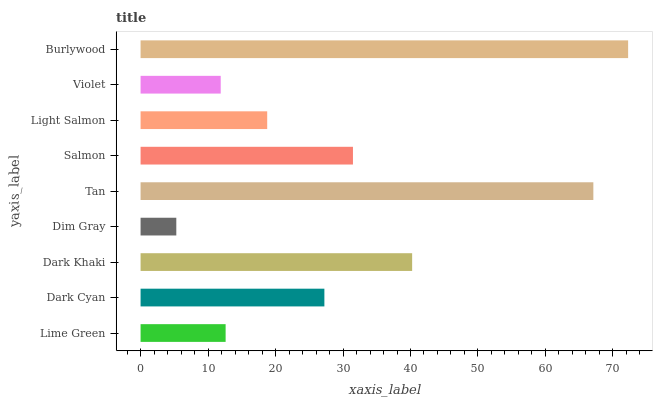Is Dim Gray the minimum?
Answer yes or no. Yes. Is Burlywood the maximum?
Answer yes or no. Yes. Is Dark Cyan the minimum?
Answer yes or no. No. Is Dark Cyan the maximum?
Answer yes or no. No. Is Dark Cyan greater than Lime Green?
Answer yes or no. Yes. Is Lime Green less than Dark Cyan?
Answer yes or no. Yes. Is Lime Green greater than Dark Cyan?
Answer yes or no. No. Is Dark Cyan less than Lime Green?
Answer yes or no. No. Is Dark Cyan the high median?
Answer yes or no. Yes. Is Dark Cyan the low median?
Answer yes or no. Yes. Is Dark Khaki the high median?
Answer yes or no. No. Is Dim Gray the low median?
Answer yes or no. No. 